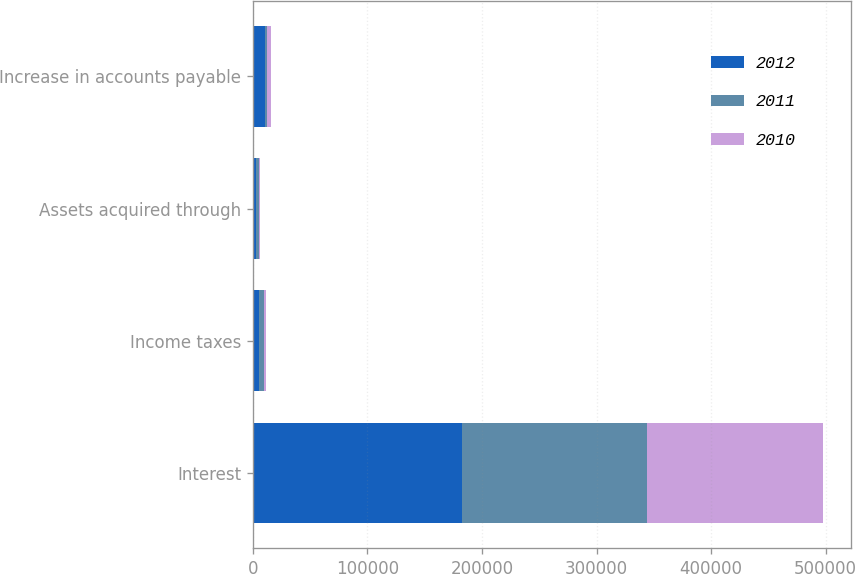Convert chart. <chart><loc_0><loc_0><loc_500><loc_500><stacked_bar_chart><ecel><fcel>Interest<fcel>Income taxes<fcel>Assets acquired through<fcel>Increase in accounts payable<nl><fcel>2012<fcel>182474<fcel>5304<fcel>2509<fcel>10166<nl><fcel>2011<fcel>161257<fcel>4218<fcel>2570<fcel>2470<nl><fcel>2010<fcel>153607<fcel>1545<fcel>1130<fcel>2800<nl></chart> 